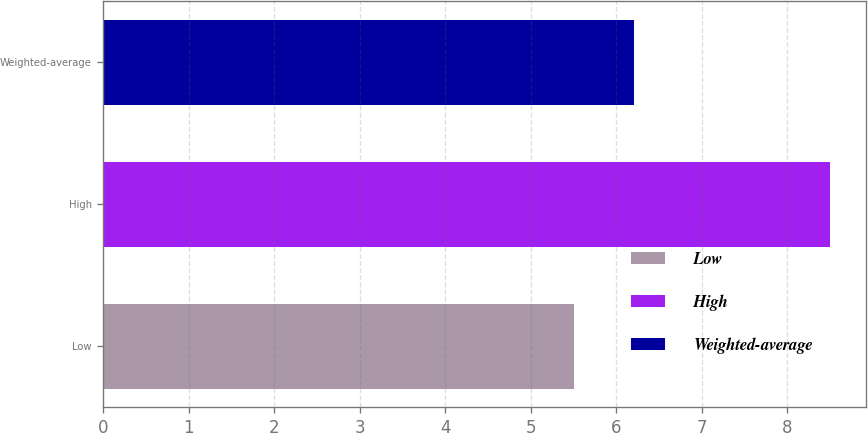<chart> <loc_0><loc_0><loc_500><loc_500><bar_chart><fcel>Low<fcel>High<fcel>Weighted-average<nl><fcel>5.5<fcel>8.5<fcel>6.2<nl></chart> 